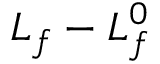<formula> <loc_0><loc_0><loc_500><loc_500>L _ { f } - L _ { f } ^ { 0 }</formula> 